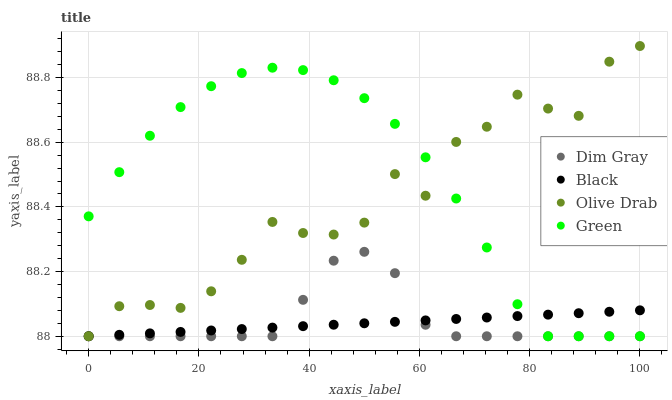Does Black have the minimum area under the curve?
Answer yes or no. Yes. Does Green have the maximum area under the curve?
Answer yes or no. Yes. Does Dim Gray have the minimum area under the curve?
Answer yes or no. No. Does Dim Gray have the maximum area under the curve?
Answer yes or no. No. Is Black the smoothest?
Answer yes or no. Yes. Is Olive Drab the roughest?
Answer yes or no. Yes. Is Dim Gray the smoothest?
Answer yes or no. No. Is Dim Gray the roughest?
Answer yes or no. No. Does Green have the lowest value?
Answer yes or no. Yes. Does Olive Drab have the highest value?
Answer yes or no. Yes. Does Dim Gray have the highest value?
Answer yes or no. No. Does Olive Drab intersect Dim Gray?
Answer yes or no. Yes. Is Olive Drab less than Dim Gray?
Answer yes or no. No. Is Olive Drab greater than Dim Gray?
Answer yes or no. No. 